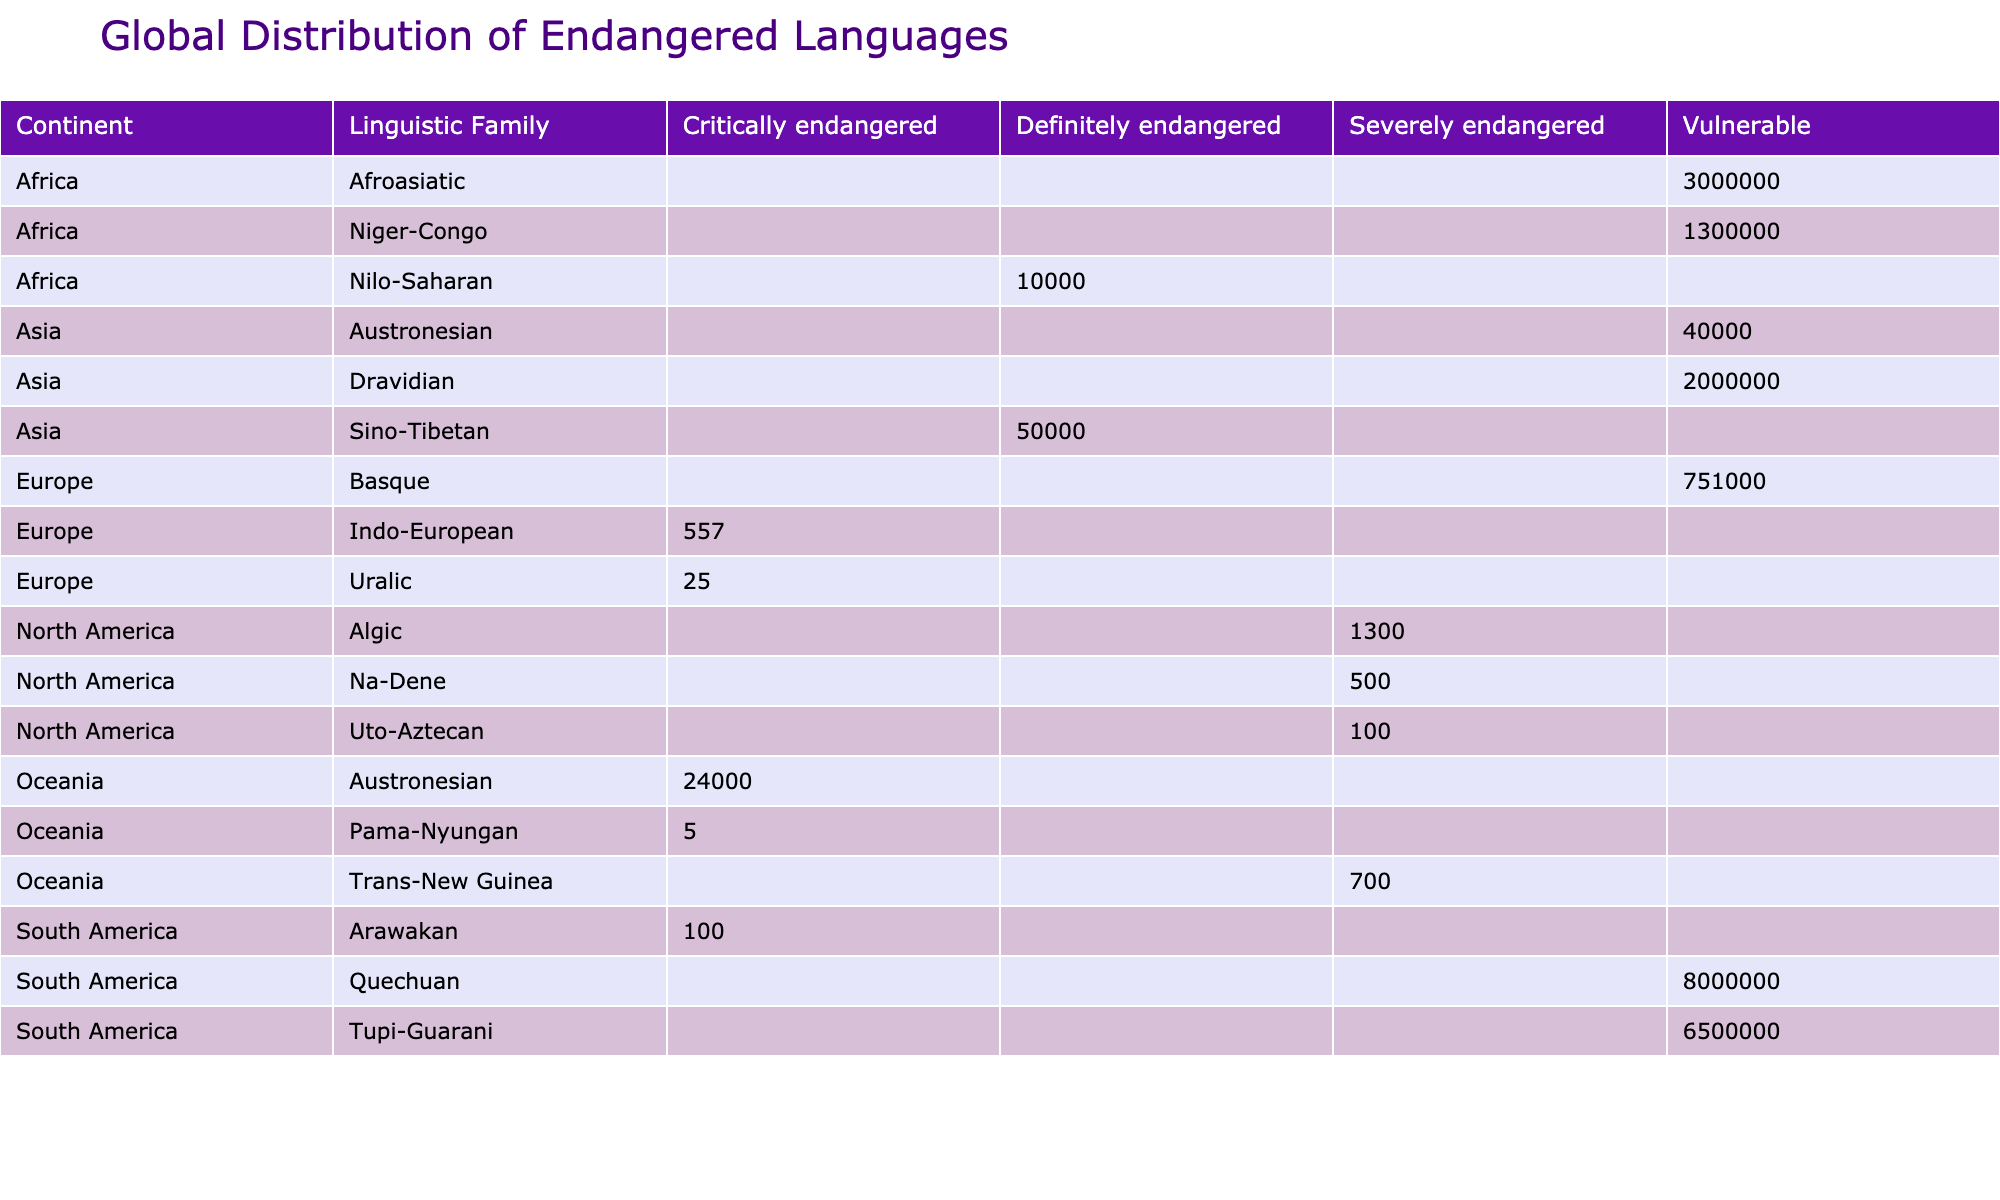What is the number of critically endangered languages in Europe? The table shows two languages with critically endangered status in Europe: Cornish and Votic.
Answer: 2 Which continent has the highest number of speakers for vulnerable languages? South America has the highest number of speakers for vulnerable languages, specifically Quechua with 8,000,000 speakers, which is higher than the vulnerable languages in other continents.
Answer: South America What is the total number of speakers for severely endangered languages across all continents? The severely endangered languages data shows Potawatomi (1,300), Tlingit (500), Comanche (100), and Skou (700). Summing these gives 1,300 + 500 + 100 + 700 = 2,600 speakers.
Answer: 2600 Is there any Afroasiatic language that is critically endangered? The table lists Tamazight as vulnerable but does not have any critically endangered Afroasiatic languages.
Answer: No Which linguistic family has the most languages listed in the table? The count of languages shows that Niger-Congo has the most languages listed in the table, with Kpelle (Vulnerable) and Ik (Definitely endangered), while other families have fewer languages.
Answer: Niger-Congo What is the endangered status of the language with the fewest speakers in Oceania? The Pama-Nyungan language Diyari is listed as critically endangered with only 5 speakers, which is the lowest in Oceania.
Answer: Critically endangered How many languages from South America are listed as vulnerable? There are two languages from South America listed as vulnerable: Quechua and Guarani.
Answer: 2 Which continent has the least speakers among its critically endangered languages? Looking at the speakers for critically endangered languages, Votic (25) and Diyari (5) are the least, but Votic is in Europe and Diyari is in Oceania. So Oceania has the least single-language speaker count for critically endangered.
Answer: Oceania What is the average number of speakers for the languages with a vulnerable status? The vulnerable languages are Kpelle (1,300,000), Tamazight (3,000,000), Kurux (2,000,000), Basque (751,000), and Quechua (8,000,000). The sum is 1,300,000 + 3,000,000 + 2,000,000 + 751,000 + 8,000,000 =  15,051,000 speakers. There are 5 languages, so the average is 15,051,000 / 5 = 3,010,200.
Answer: 3010200 Are there any languages listed with the status of "definitely endangered"? Yes, the table lists two languages with a definitely endangered status, Lepcha and Ik.
Answer: Yes 